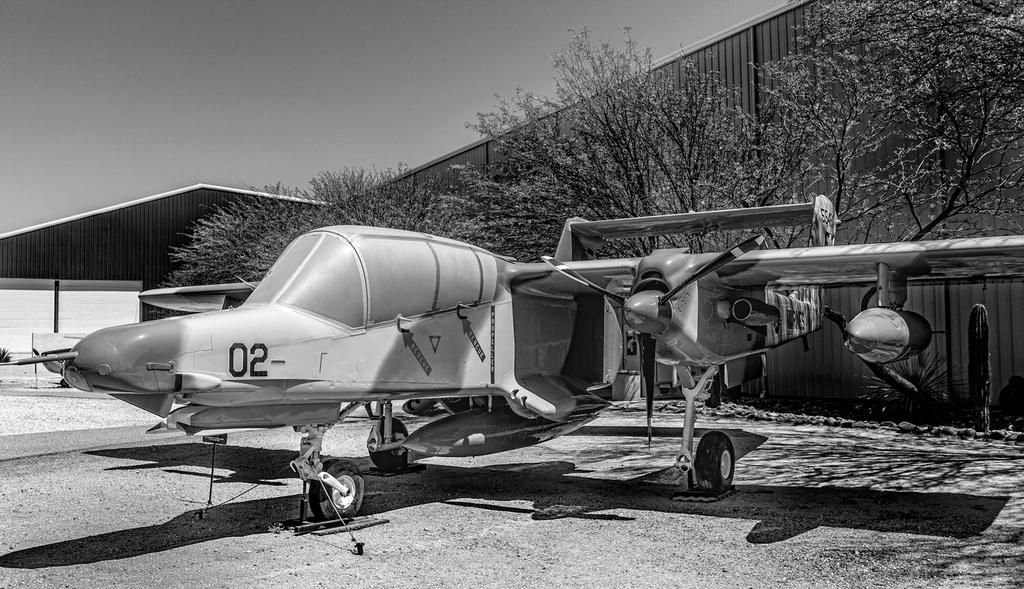<image>
Describe the image concisely. a small old plane with 02 on its nose sits near a hangar 